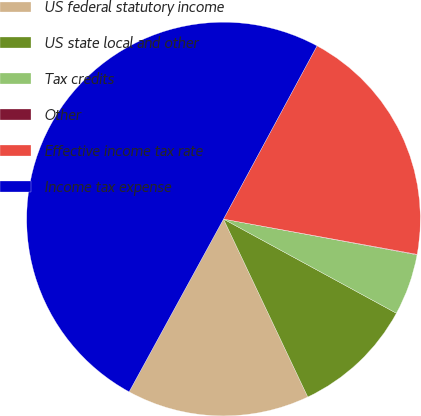Convert chart. <chart><loc_0><loc_0><loc_500><loc_500><pie_chart><fcel>US federal statutory income<fcel>US state local and other<fcel>Tax credits<fcel>Other<fcel>Effective income tax rate<fcel>Income tax expense<nl><fcel>15.0%<fcel>10.02%<fcel>5.03%<fcel>0.04%<fcel>19.99%<fcel>49.92%<nl></chart> 